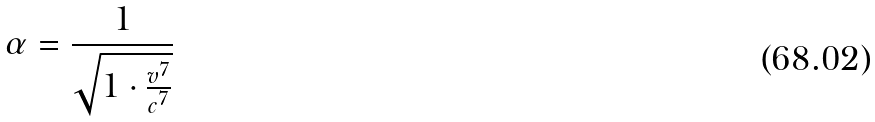<formula> <loc_0><loc_0><loc_500><loc_500>\alpha = \frac { 1 } { \sqrt { 1 \cdot \frac { v ^ { 7 } } { c ^ { 7 } } } }</formula> 